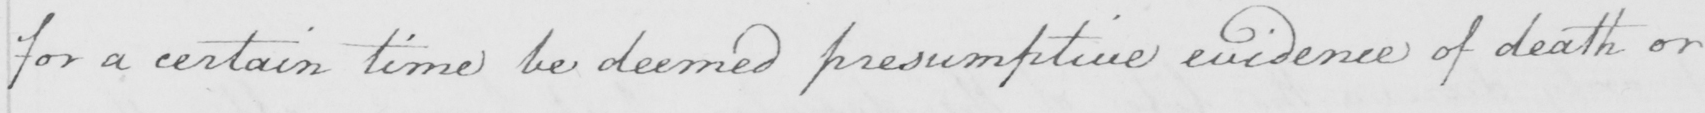What does this handwritten line say? for a certain time be deemed presumptive evidence of death or 